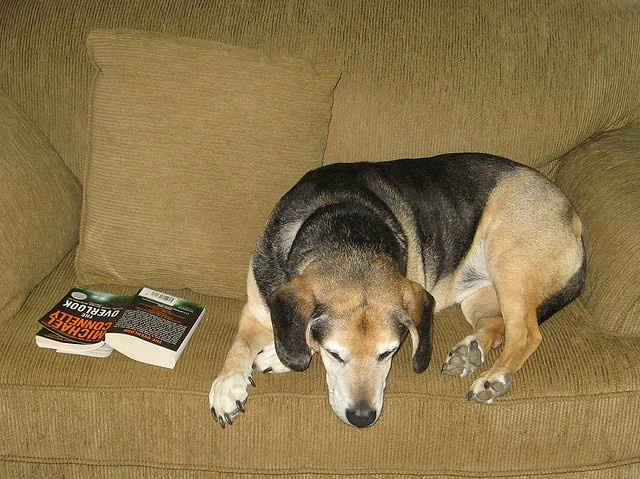Describe the objects in this image and their specific colors. I can see couch in tan, olive, and black tones, dog in gray, black, and tan tones, and book in olive, black, beige, gray, and darkgray tones in this image. 